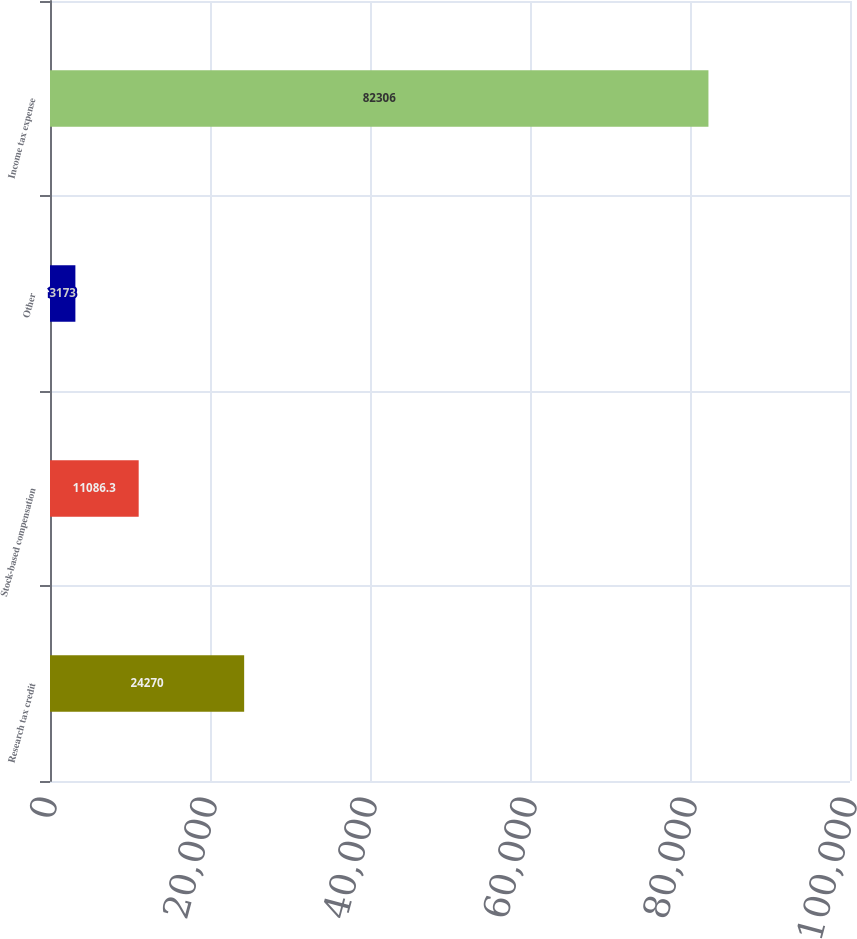Convert chart. <chart><loc_0><loc_0><loc_500><loc_500><bar_chart><fcel>Research tax credit<fcel>Stock-based compensation<fcel>Other<fcel>Income tax expense<nl><fcel>24270<fcel>11086.3<fcel>3173<fcel>82306<nl></chart> 